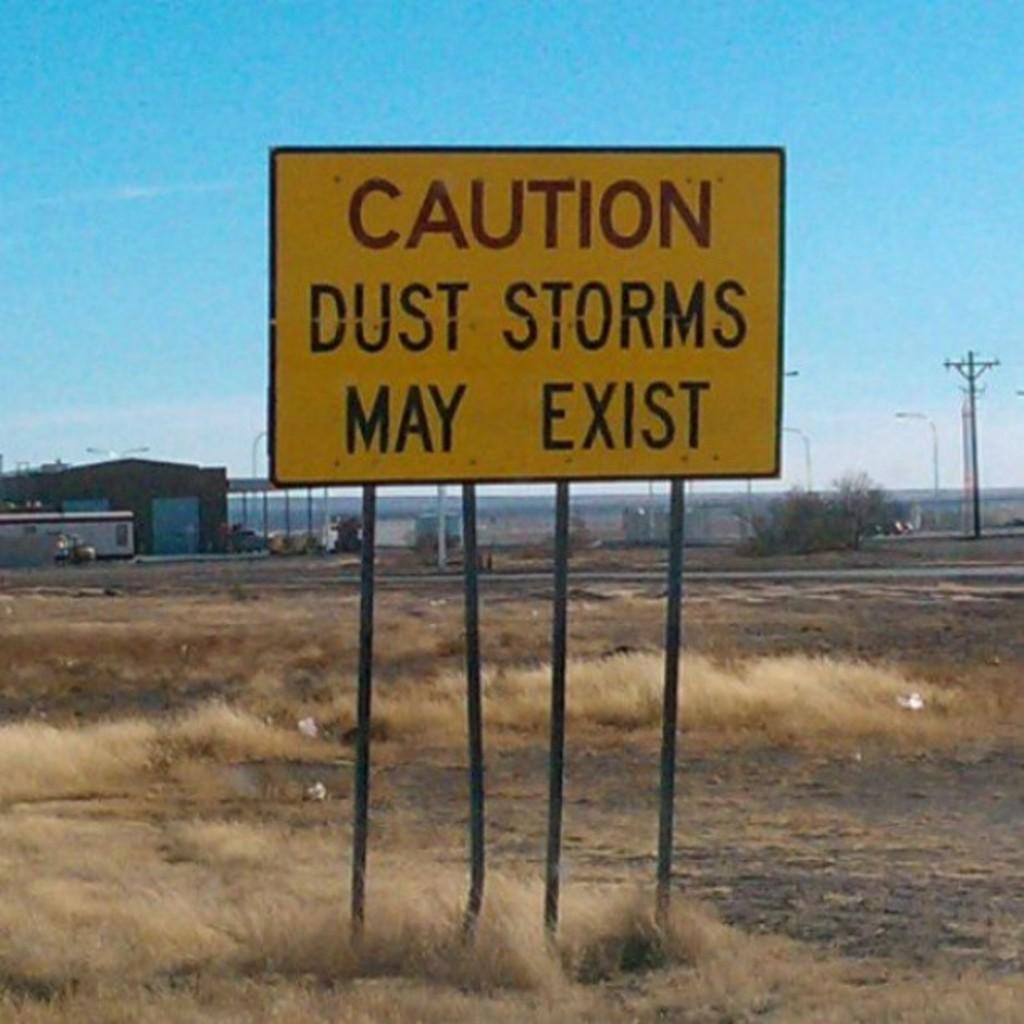What kind of sign is this?
Your response must be concise. Caution. 